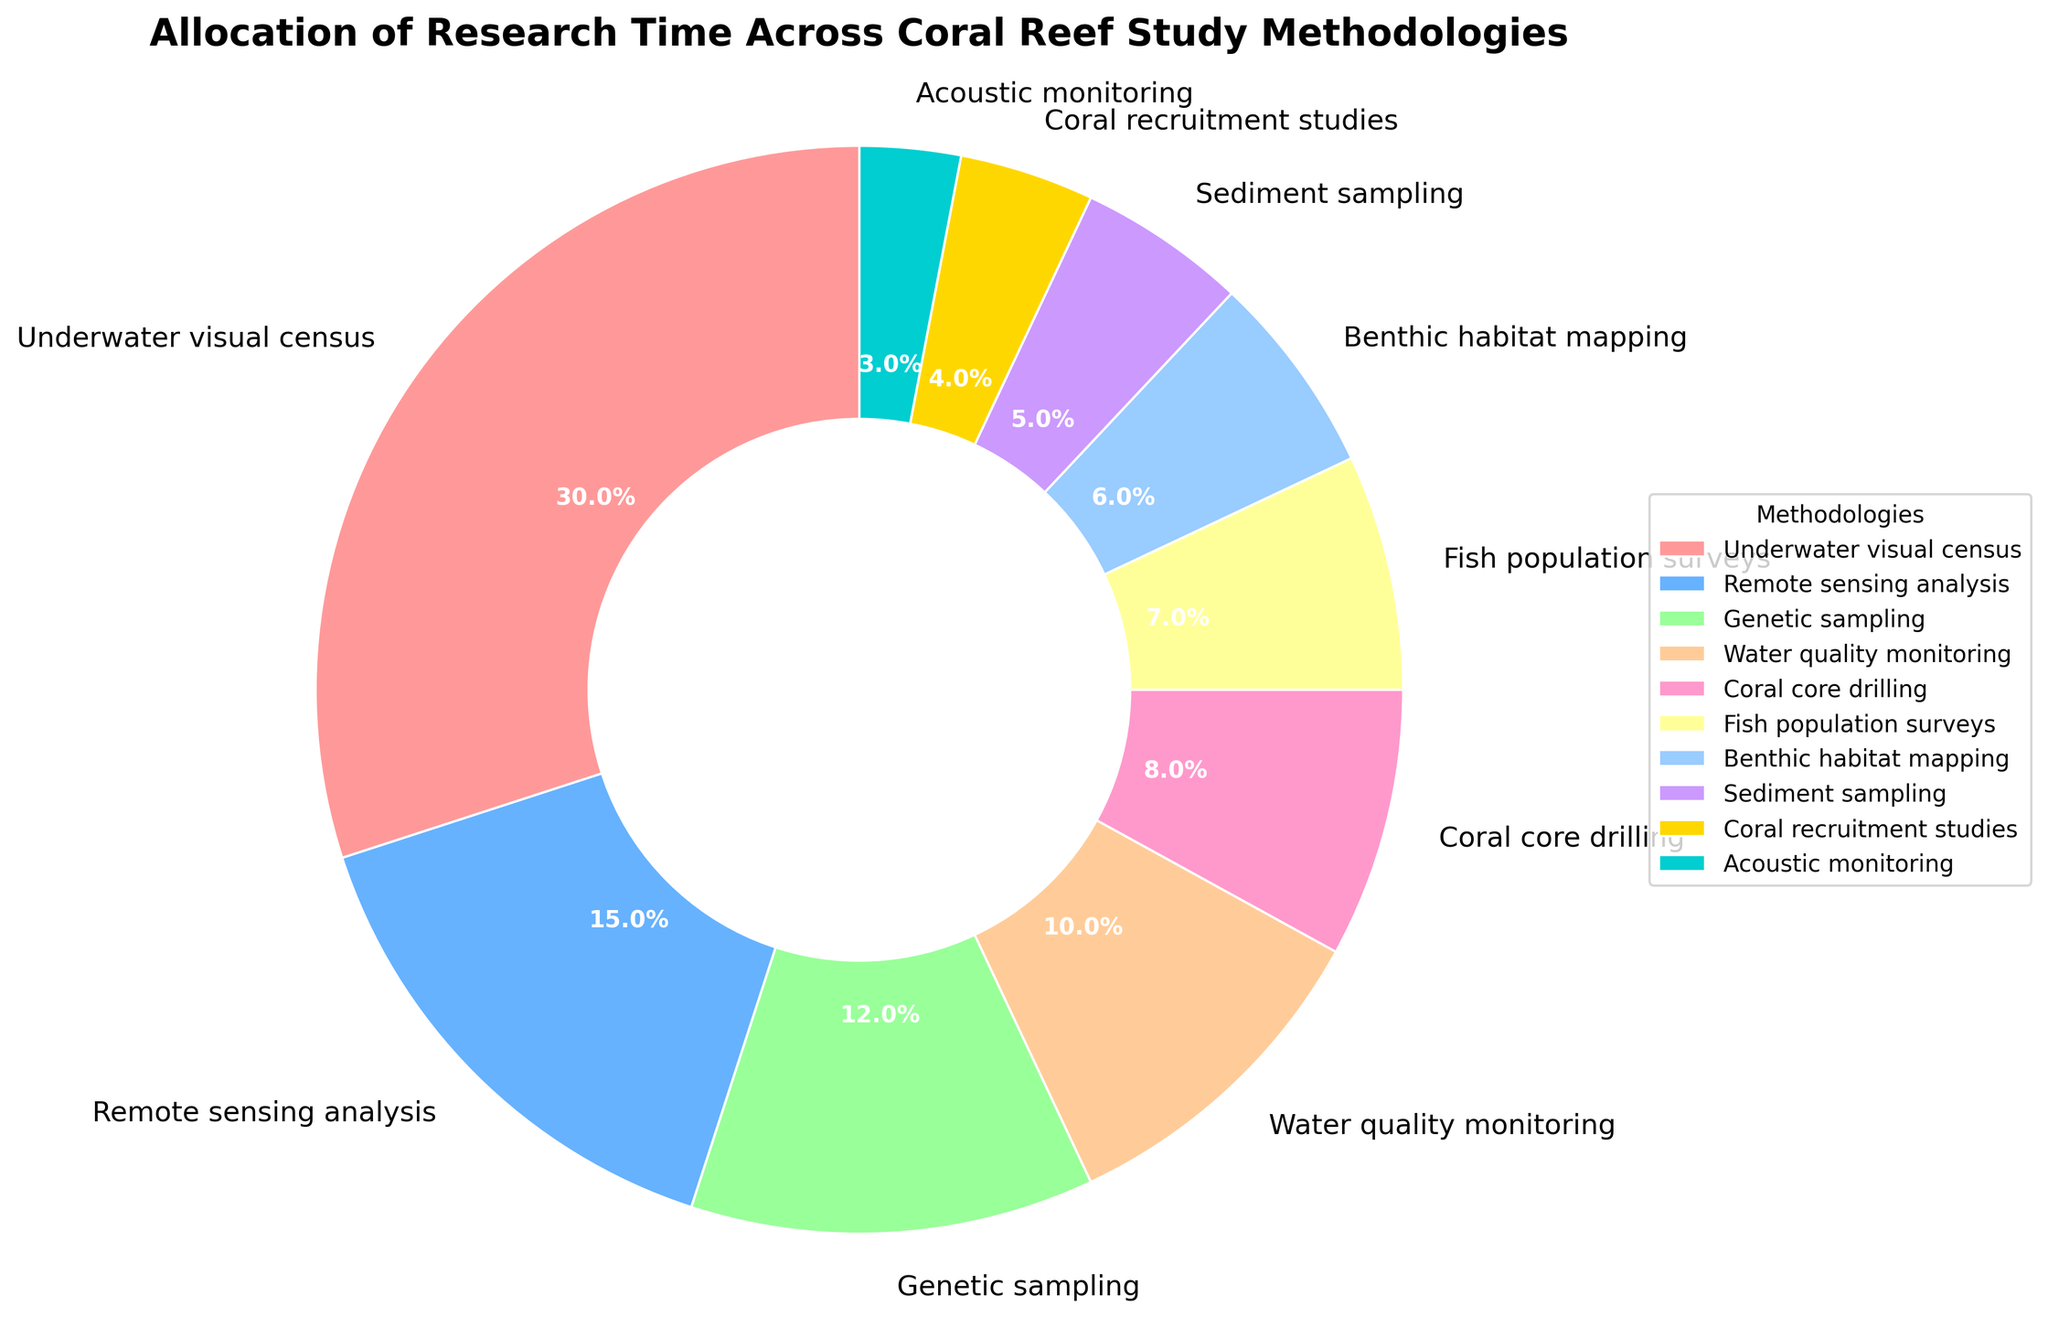What's the total percentage allocation for methodologies involving direct observation? To find the total percentage allocation for methodologies involving direct observation, we add the percentages for "Underwater visual census" and "Fish population surveys". The sum is 30% + 7% = 37%.
Answer: 37% How do the percentages for "Genetic sampling" and "Water quality monitoring" compare? To compare the percentages, check the data for "Genetic sampling" (12%) and "Water quality monitoring" (10%). Since 12% is greater than 10%, "Genetic sampling" has a higher percentage.
Answer: Genetic sampling has a higher percentage What's the smallest percentage allocation among the methodologies? Identify the methodology with the smallest percentage by looking for the smallest value. The smallest percentage allocation is for "Acoustic monitoring" at 3%.
Answer: Acoustic monitoring Is the combined allocation of "Remote sensing analysis" and "Benthic habitat mapping" more than that of "Underwater visual census"? Sum the percentages for "Remote sensing analysis" (15%) and "Benthic habitat mapping" (6%). The sum is 15% + 6% = 21%. Compare this with "Underwater visual census" (30%). Since 21% is less than 30%, the combined allocation is not more.
Answer: No What could be the reason for the high allocation to "Underwater visual census" compared to other methodologies? This question is more interpretive, requiring reasoning beyond the visual data. "Underwater visual census" might have a high allocation because it's a fundamental and versatile method used for broad and immediate assessments of coral reefs.
Answer: Versatility and fundamental use Calculate the difference in percentage allocation between "Coral core drilling" and "Sediment sampling". Find the percentages for "Coral core drilling" (8%) and "Sediment sampling" (5%). Compute the difference: 8% - 5% = 3%.
Answer: 3% How does the percentage for "Coral recruitment studies" compare to the average of all other methodologies? First, sum the percentages of all methodologies excluding "Coral recruitment studies": 30% + 15% + 12% + 10% + 8% + 7% + 6% + 5% + 3% = 96%. There are 9 methodologies, so the average is 96%/9 ≈ 10.67%. "Coral recruitment studies" (4%) is less than this average.
Answer: Less Which visual attribute helps in distinguishing the "Fish population surveys" slice? Look for attributes like color and label. "Fish population surveys" is distinguished by its label and its distinct blue color.
Answer: Label and blue color Assuming the total available research time is 1000 hours, how many hours are allocated to "Water quality monitoring"? The percentage for "Water quality monitoring" is 10%. Calculate the allocated hours as 10% of 1000 hours, which is 0.10 * 1000 = 100 hours.
Answer: 100 hours What's the combined allocation for methodologies related to habitat and environmental quality monitoring? To find the combined allocation, sum the percentages for "Water quality monitoring" (10%), "Benthic habitat mapping" (6%), and "Sediment sampling" (5%). The total is 10% + 6% + 5% = 21%.
Answer: 21% 